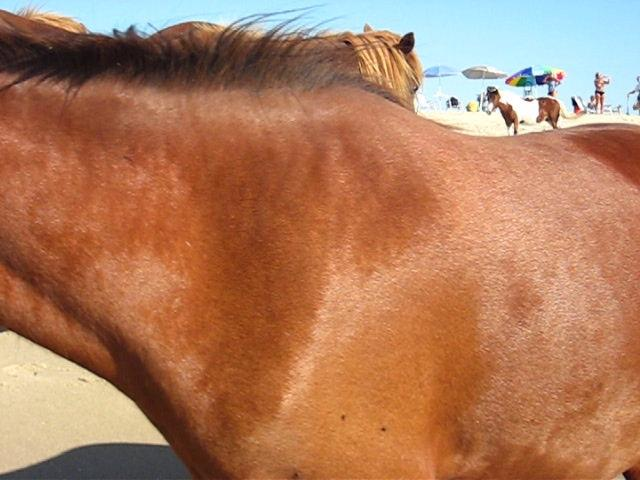What type flag elements appear in a pictured umbrella?

Choices:
A) nazi
B) american
C) gay rainbow
D) chilean gay rainbow 